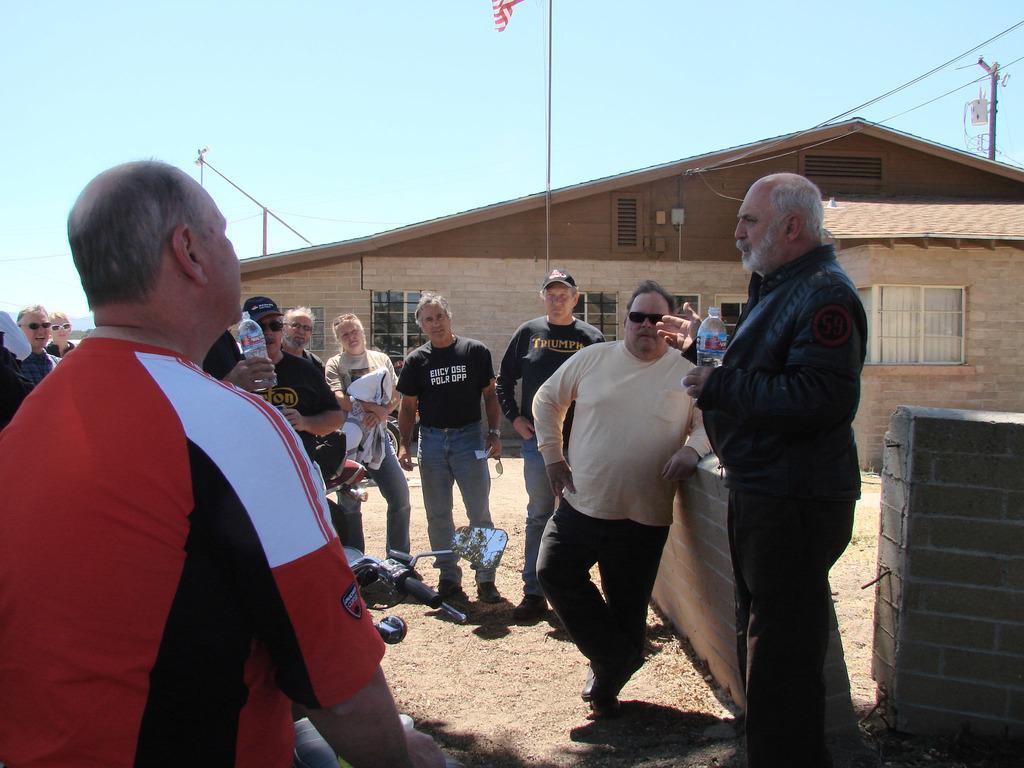Could you give a brief overview of what you see in this image? There are groups of people standing. This looks like a motorbike. I can see two people holding water bottles in their hands. This looks like a pole. I think this is a house with the windows. On the right side of the image, that looks like a current pole. This is the wall. 